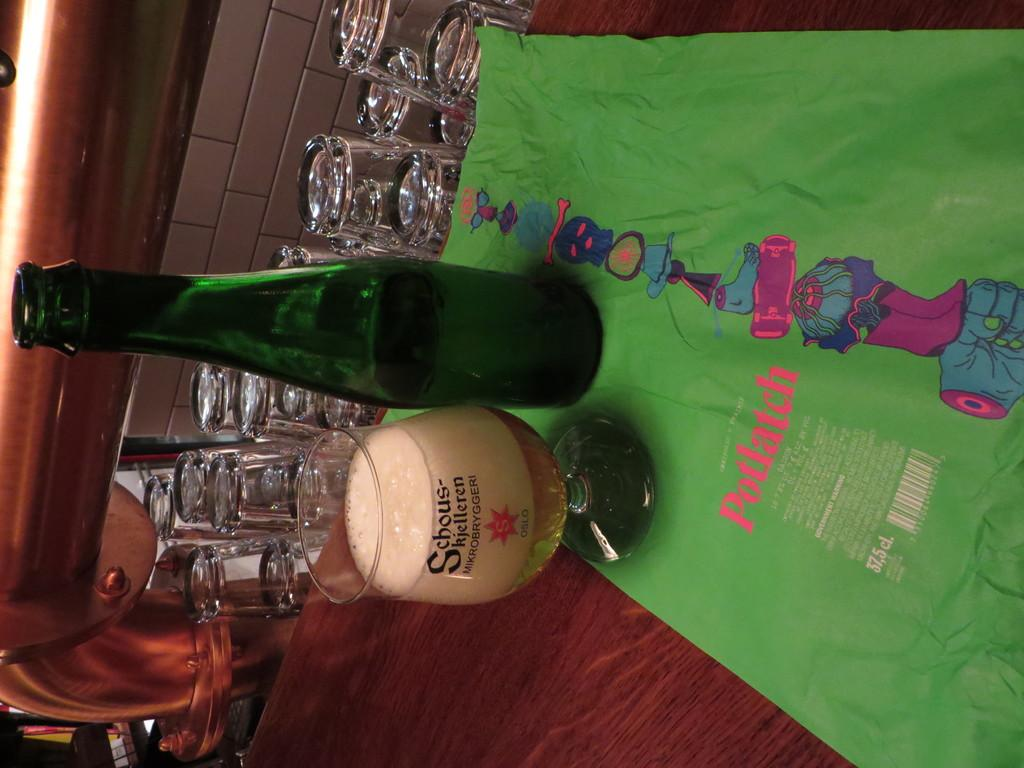<image>
Give a short and clear explanation of the subsequent image. a sidways view of a green bottle and a glass of beer with the word potlatch on a green cloth 